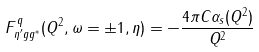<formula> <loc_0><loc_0><loc_500><loc_500>F _ { \eta ^ { \prime } g g ^ { \ast } } ^ { q } ( Q ^ { 2 } , \omega = \pm 1 , \eta ) = - \frac { 4 \pi C \alpha _ { s } ( Q ^ { 2 } ) } { Q ^ { 2 } }</formula> 